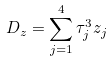<formula> <loc_0><loc_0><loc_500><loc_500>D _ { z } = \sum _ { j = 1 } ^ { 4 } \tau _ { j } ^ { 3 } z _ { j } \,</formula> 